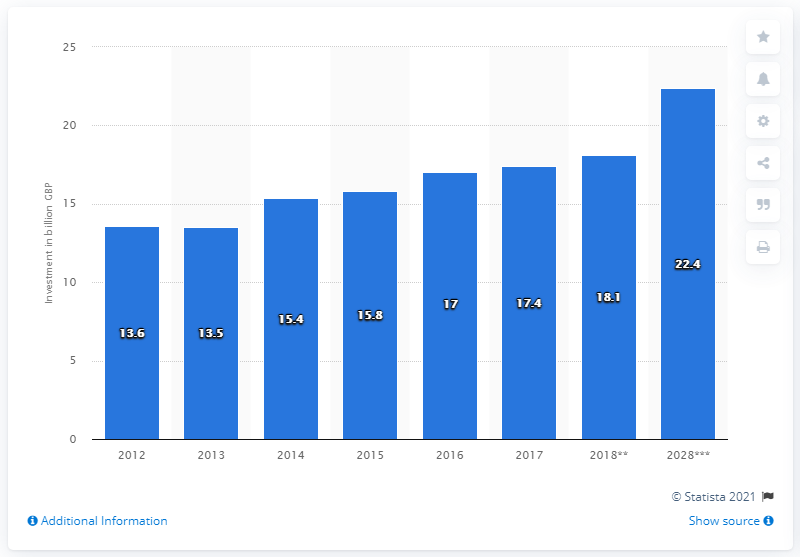Highlight a few significant elements in this photo. In 2017, the total amount of capital investment spending in the UK was 17.4 billion pounds. 